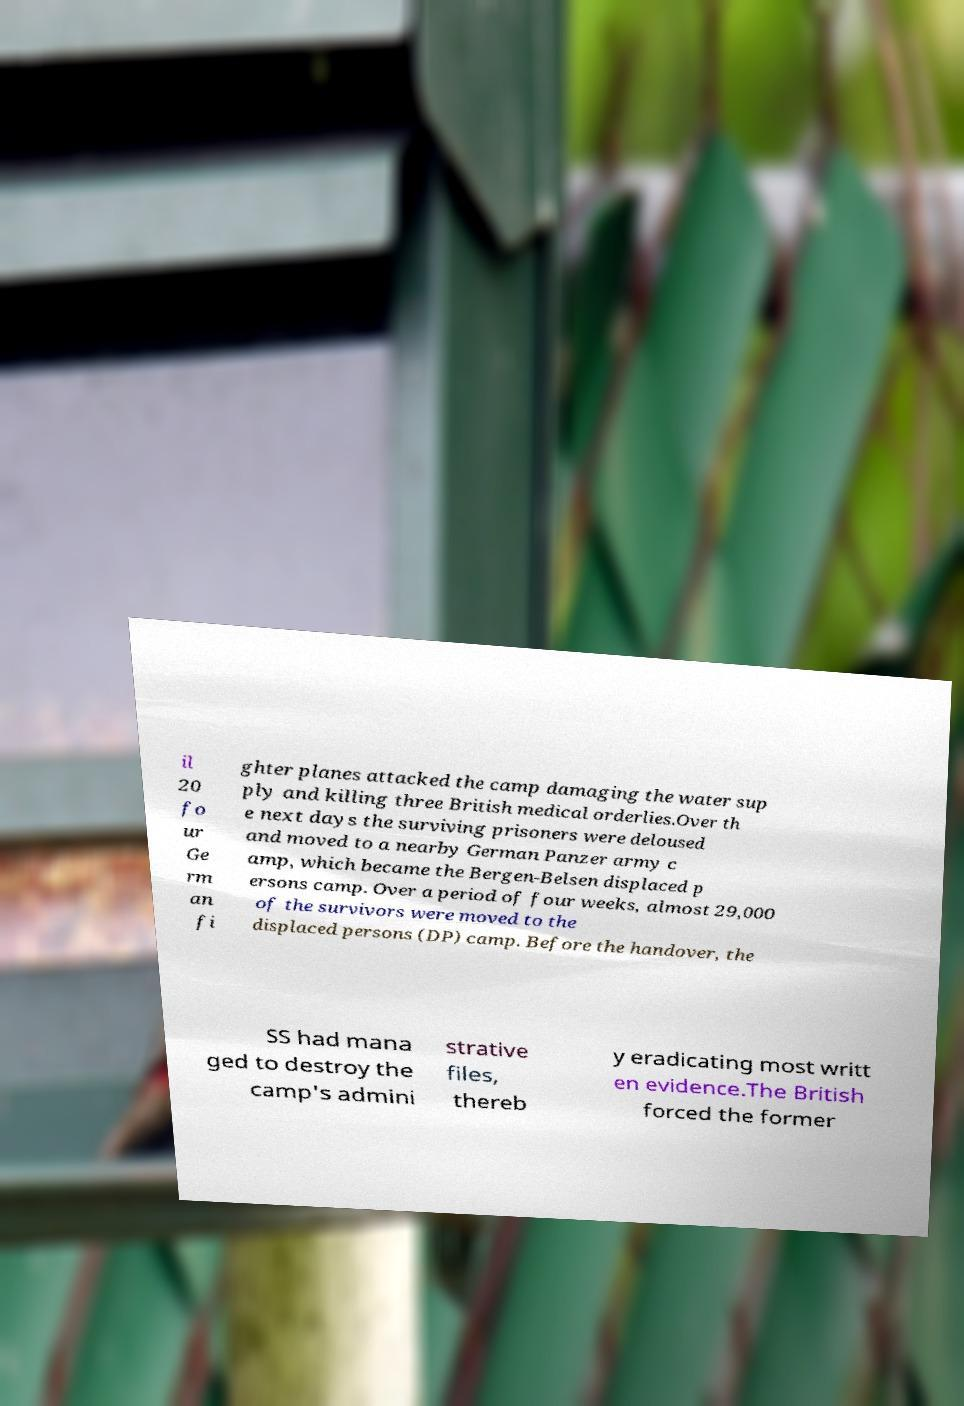I need the written content from this picture converted into text. Can you do that? il 20 fo ur Ge rm an fi ghter planes attacked the camp damaging the water sup ply and killing three British medical orderlies.Over th e next days the surviving prisoners were deloused and moved to a nearby German Panzer army c amp, which became the Bergen-Belsen displaced p ersons camp. Over a period of four weeks, almost 29,000 of the survivors were moved to the displaced persons (DP) camp. Before the handover, the SS had mana ged to destroy the camp's admini strative files, thereb y eradicating most writt en evidence.The British forced the former 